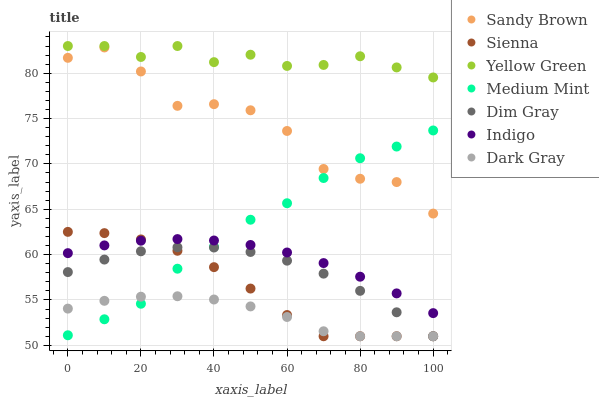Does Dark Gray have the minimum area under the curve?
Answer yes or no. Yes. Does Yellow Green have the maximum area under the curve?
Answer yes or no. Yes. Does Dim Gray have the minimum area under the curve?
Answer yes or no. No. Does Dim Gray have the maximum area under the curve?
Answer yes or no. No. Is Indigo the smoothest?
Answer yes or no. Yes. Is Sandy Brown the roughest?
Answer yes or no. Yes. Is Dark Gray the smoothest?
Answer yes or no. No. Is Dark Gray the roughest?
Answer yes or no. No. Does Dark Gray have the lowest value?
Answer yes or no. Yes. Does Indigo have the lowest value?
Answer yes or no. No. Does Yellow Green have the highest value?
Answer yes or no. Yes. Does Dim Gray have the highest value?
Answer yes or no. No. Is Dark Gray less than Yellow Green?
Answer yes or no. Yes. Is Yellow Green greater than Indigo?
Answer yes or no. Yes. Does Dim Gray intersect Sienna?
Answer yes or no. Yes. Is Dim Gray less than Sienna?
Answer yes or no. No. Is Dim Gray greater than Sienna?
Answer yes or no. No. Does Dark Gray intersect Yellow Green?
Answer yes or no. No. 